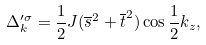Convert formula to latex. <formula><loc_0><loc_0><loc_500><loc_500>\Delta _ { k } ^ { \prime \sigma } = { \frac { 1 } { 2 } } J ( { \overline { s } } ^ { 2 } + { \overline { t } } ^ { 2 } ) \cos { \frac { 1 } { 2 } } k _ { z } ,</formula> 